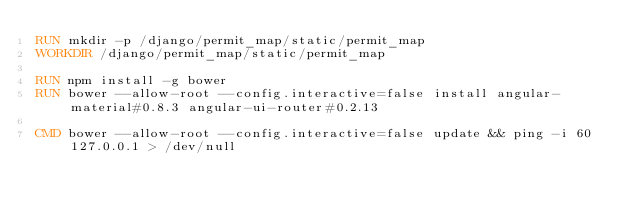Convert code to text. <code><loc_0><loc_0><loc_500><loc_500><_Dockerfile_>RUN mkdir -p /django/permit_map/static/permit_map
WORKDIR /django/permit_map/static/permit_map

RUN npm install -g bower
RUN bower --allow-root --config.interactive=false install angular-material#0.8.3 angular-ui-router#0.2.13

CMD bower --allow-root --config.interactive=false update && ping -i 60 127.0.0.1 > /dev/null
</code> 